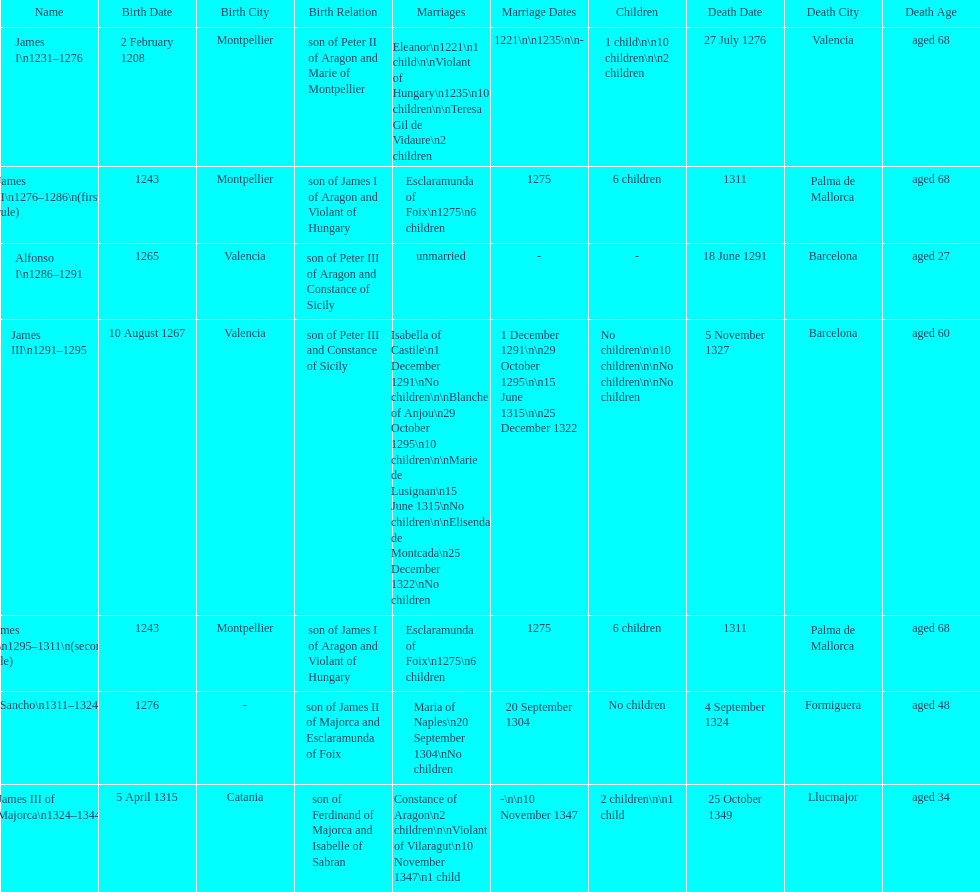How many of these monarchs died before the age of 65? 4. 